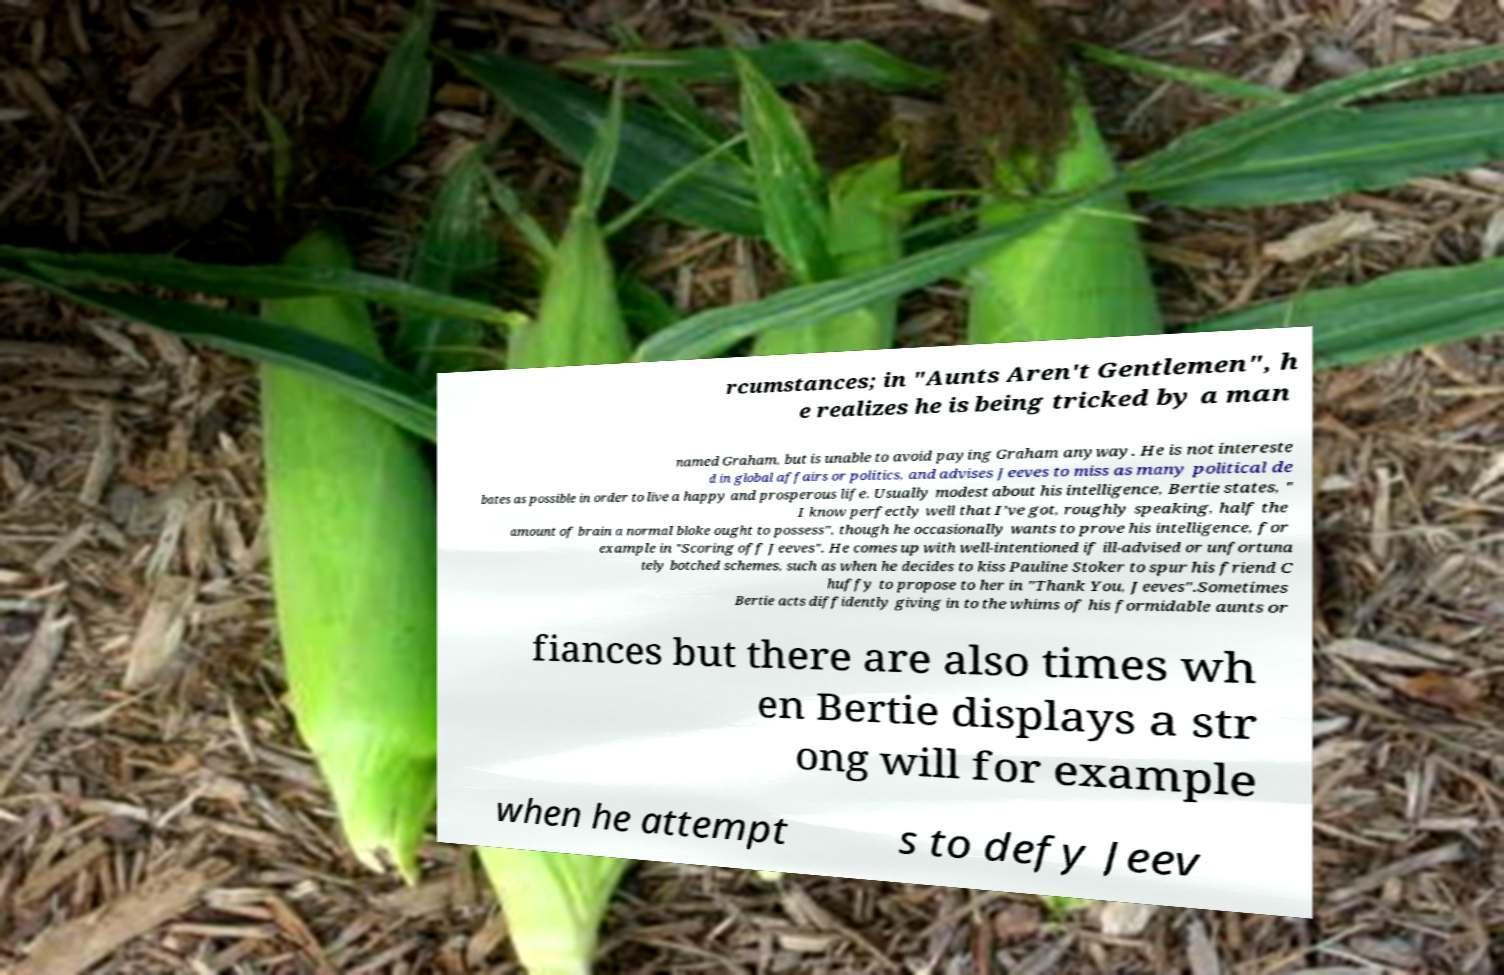Can you accurately transcribe the text from the provided image for me? rcumstances; in "Aunts Aren't Gentlemen", h e realizes he is being tricked by a man named Graham, but is unable to avoid paying Graham anyway. He is not intereste d in global affairs or politics, and advises Jeeves to miss as many political de bates as possible in order to live a happy and prosperous life. Usually modest about his intelligence, Bertie states, " I know perfectly well that I've got, roughly speaking, half the amount of brain a normal bloke ought to possess", though he occasionally wants to prove his intelligence, for example in "Scoring off Jeeves". He comes up with well-intentioned if ill-advised or unfortuna tely botched schemes, such as when he decides to kiss Pauline Stoker to spur his friend C huffy to propose to her in "Thank You, Jeeves".Sometimes Bertie acts diffidently giving in to the whims of his formidable aunts or fiances but there are also times wh en Bertie displays a str ong will for example when he attempt s to defy Jeev 